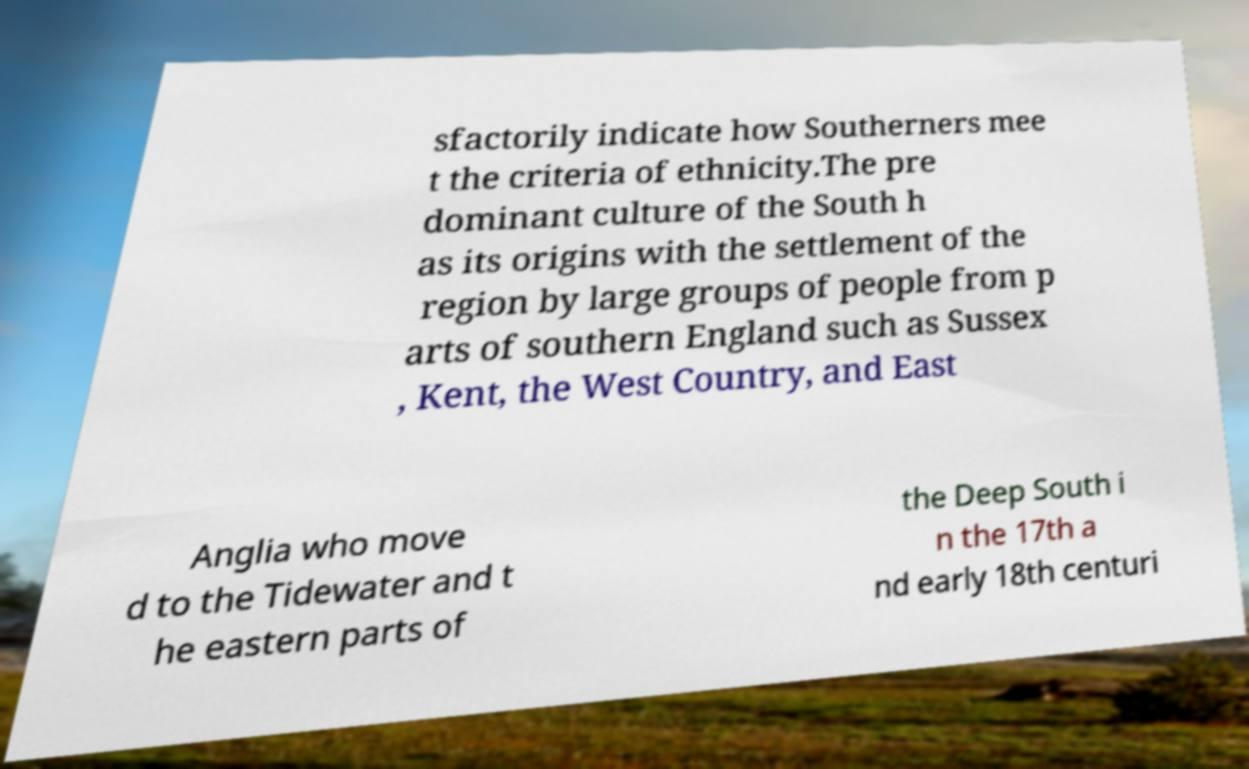I need the written content from this picture converted into text. Can you do that? sfactorily indicate how Southerners mee t the criteria of ethnicity.The pre dominant culture of the South h as its origins with the settlement of the region by large groups of people from p arts of southern England such as Sussex , Kent, the West Country, and East Anglia who move d to the Tidewater and t he eastern parts of the Deep South i n the 17th a nd early 18th centuri 